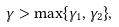<formula> <loc_0><loc_0><loc_500><loc_500>\gamma > \max \{ \gamma _ { 1 } , \gamma _ { 2 } \} ,</formula> 